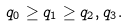<formula> <loc_0><loc_0><loc_500><loc_500>q _ { 0 } \geq q _ { 1 } \geq q _ { 2 } , q _ { 3 } .</formula> 